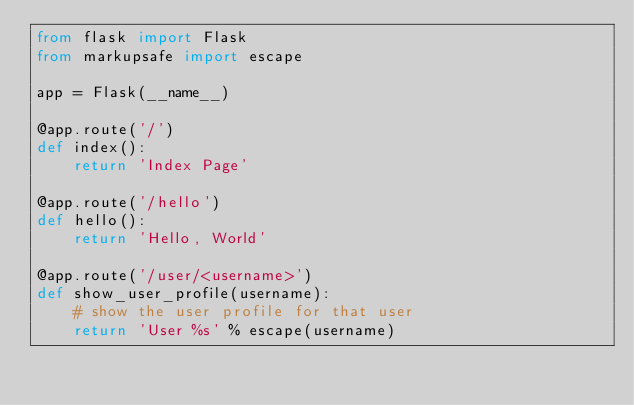Convert code to text. <code><loc_0><loc_0><loc_500><loc_500><_Python_>from flask import Flask
from markupsafe import escape

app = Flask(__name__)

@app.route('/')
def index():
    return 'Index Page'

@app.route('/hello')
def hello():
    return 'Hello, World'

@app.route('/user/<username>')
def show_user_profile(username):
    # show the user profile for that user
    return 'User %s' % escape(username)</code> 